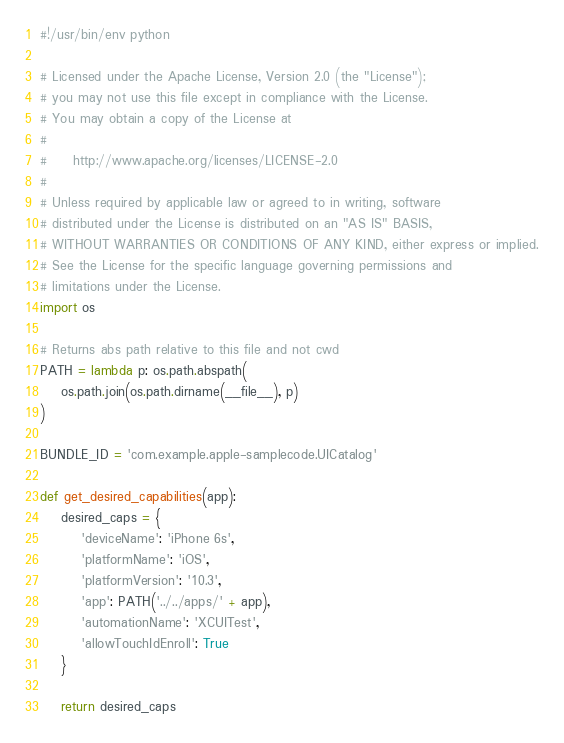Convert code to text. <code><loc_0><loc_0><loc_500><loc_500><_Python_>#!/usr/bin/env python

# Licensed under the Apache License, Version 2.0 (the "License");
# you may not use this file except in compliance with the License.
# You may obtain a copy of the License at
#
#     http://www.apache.org/licenses/LICENSE-2.0
#
# Unless required by applicable law or agreed to in writing, software
# distributed under the License is distributed on an "AS IS" BASIS,
# WITHOUT WARRANTIES OR CONDITIONS OF ANY KIND, either express or implied.
# See the License for the specific language governing permissions and
# limitations under the License.
import os

# Returns abs path relative to this file and not cwd
PATH = lambda p: os.path.abspath(
    os.path.join(os.path.dirname(__file__), p)
)

BUNDLE_ID = 'com.example.apple-samplecode.UICatalog'

def get_desired_capabilities(app):
    desired_caps = {
        'deviceName': 'iPhone 6s',
        'platformName': 'iOS',
        'platformVersion': '10.3',
        'app': PATH('../../apps/' + app),
        'automationName': 'XCUITest',
        'allowTouchIdEnroll': True
    }

    return desired_caps
</code> 